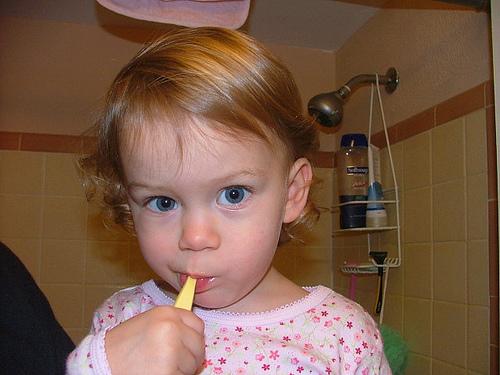What room is the girl in?
Be succinct. Bathroom. Is she being taught?
Write a very short answer. Yes. What is she holding in her mouth?
Give a very brief answer. Toothbrush. 